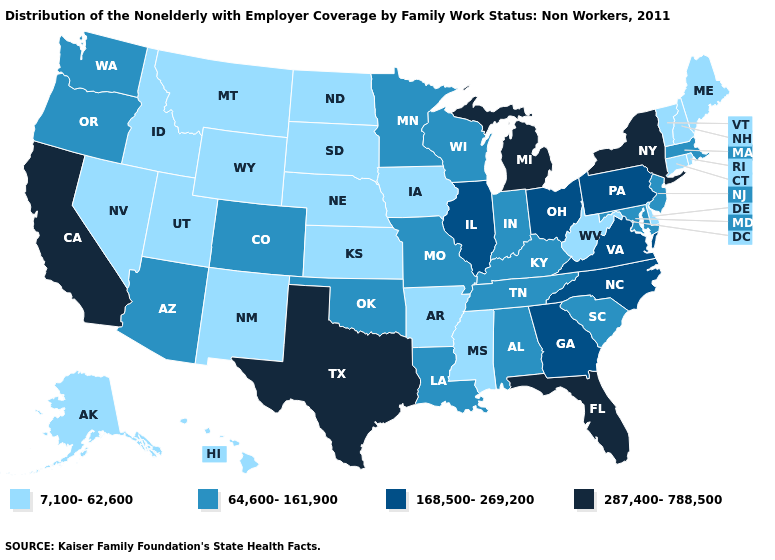What is the highest value in the South ?
Quick response, please. 287,400-788,500. Does Rhode Island have the highest value in the Northeast?
Keep it brief. No. Does Wyoming have the same value as Nebraska?
Concise answer only. Yes. What is the value of Idaho?
Concise answer only. 7,100-62,600. What is the highest value in the Northeast ?
Keep it brief. 287,400-788,500. How many symbols are there in the legend?
Keep it brief. 4. What is the highest value in the USA?
Keep it brief. 287,400-788,500. What is the highest value in the USA?
Write a very short answer. 287,400-788,500. Name the states that have a value in the range 64,600-161,900?
Answer briefly. Alabama, Arizona, Colorado, Indiana, Kentucky, Louisiana, Maryland, Massachusetts, Minnesota, Missouri, New Jersey, Oklahoma, Oregon, South Carolina, Tennessee, Washington, Wisconsin. Which states have the lowest value in the MidWest?
Write a very short answer. Iowa, Kansas, Nebraska, North Dakota, South Dakota. Does Arkansas have the lowest value in the South?
Give a very brief answer. Yes. Does the first symbol in the legend represent the smallest category?
Write a very short answer. Yes. Does the map have missing data?
Short answer required. No. What is the value of Colorado?
Answer briefly. 64,600-161,900. What is the lowest value in the USA?
Keep it brief. 7,100-62,600. 